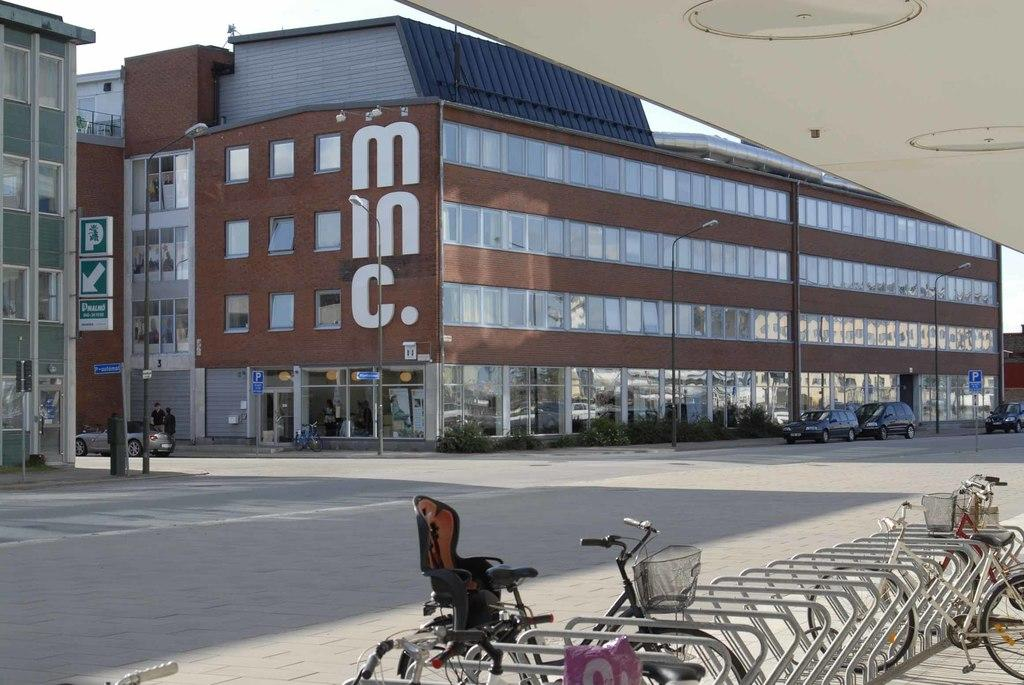What type of structures can be seen in the image? There are buildings in the image. What type of lighting is present in the image? Street lights are present in the image. What type of vertical structures can be seen in the image? Street poles are visible in the image. What type of signage is present in the image? Sign boards are in the image. What type of transportation is on the road in the image? Motor vehicles are on the road in the image. Are there any people visible in the image? Yes, there are persons standing on the road in the image. Where are the bicycles located in the image? Bicycles are in the bicycle stand in the image. What type of boot is being worn by the person standing on the road in the image? There is no information about the type of footwear worn by the person in the image. What type of bottle is being held by the person standing on the road in the image? There is no information about any bottles being held by the person in the image. 